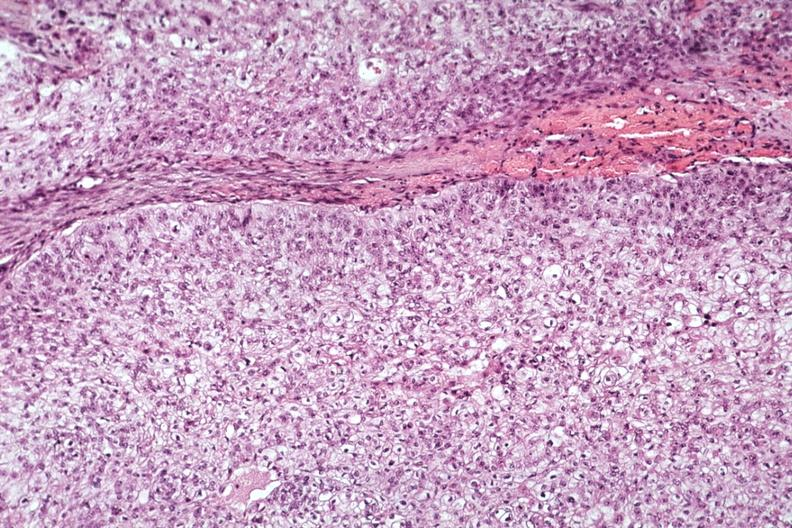what does this image show?
Answer the question using a single word or phrase. Good photo of tumor cells 